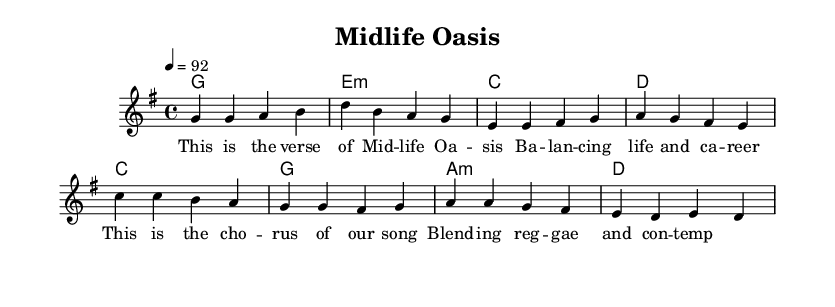What is the key signature of this music? The key signature is G major, indicated by the one sharp (F#) in the key signature marking at the beginning of the staff.
Answer: G major What is the time signature of this piece? The time signature indicated on the sheet music is 4/4, shown at the beginning next to the key signature. This means there are four beats in each measure, and the quarter note gets one beat.
Answer: 4/4 What is the tempo marking of the piece? The tempo marking is a quarter note equals 92, indicating the speed at which the music should be played. This is specified in the tempo indication near the beginning of the score.
Answer: 92 How many measures are there in the verse? The verse consists of four measures as shown in the melody section of the score, which contains a group of notes divided into those four measures.
Answer: 4 What chords are used in the chorus? The chords in the chorus include C, G, A minor, and D, as indicated in the chord names section right after the melody line for the chorus.
Answer: C, G, A minor, D What is the overall theme suggested by the lyrics? The lyrics suggest a theme of balancing life and career, as indicated by the words in the verse line stating “Balancing life and career.” This reflects the adult contemporary themes combined with reggae stylings.
Answer: Balancing life and career How does the structure of this piece compare to traditional reggae? The structure blends traditional verse-chorus form typical of reggae with adult contemporary lyrical themes, diverging from the typical socially conscious or rhythm-focused reggae lyrics often found in traditional reggae music.
Answer: Blends traditional and contemporary themes 